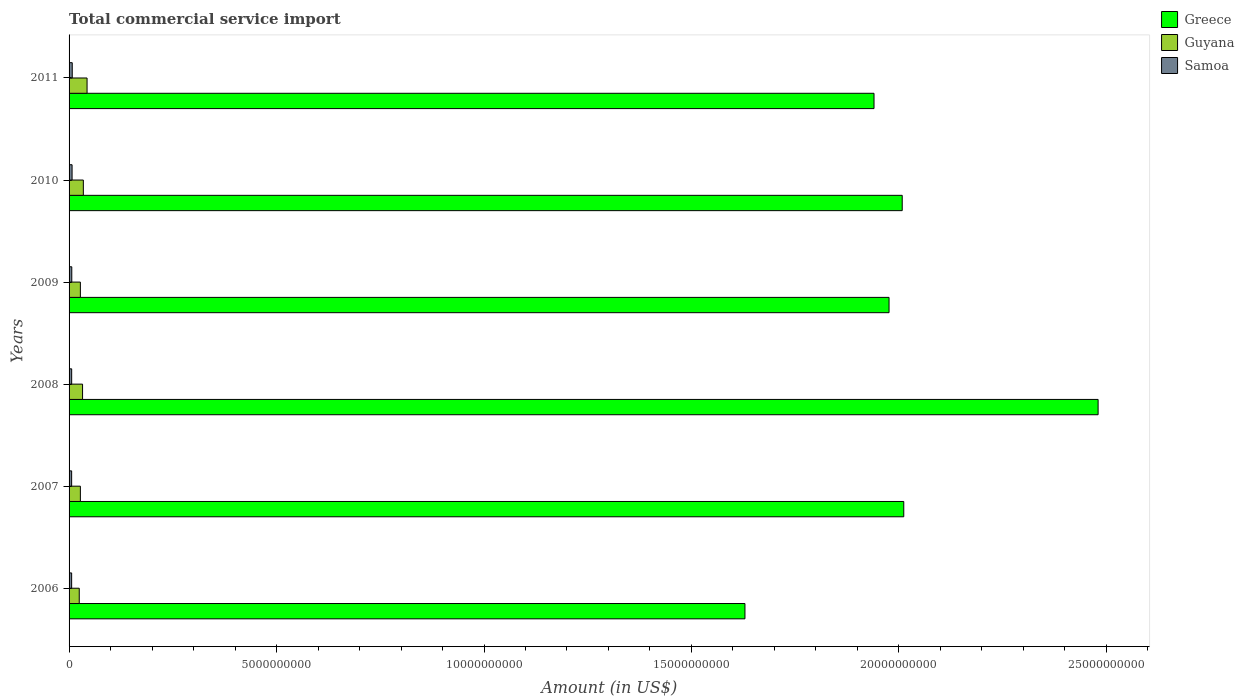How many different coloured bars are there?
Make the answer very short. 3. How many groups of bars are there?
Make the answer very short. 6. Are the number of bars per tick equal to the number of legend labels?
Provide a succinct answer. Yes. How many bars are there on the 1st tick from the top?
Your response must be concise. 3. What is the label of the 6th group of bars from the top?
Make the answer very short. 2006. What is the total commercial service import in Guyana in 2009?
Offer a terse response. 2.72e+08. Across all years, what is the maximum total commercial service import in Greece?
Give a very brief answer. 2.48e+1. Across all years, what is the minimum total commercial service import in Samoa?
Make the answer very short. 6.19e+07. In which year was the total commercial service import in Greece minimum?
Give a very brief answer. 2006. What is the total total commercial service import in Samoa in the graph?
Your answer should be very brief. 4.01e+08. What is the difference between the total commercial service import in Guyana in 2008 and that in 2009?
Provide a succinct answer. 5.28e+07. What is the difference between the total commercial service import in Samoa in 2006 and the total commercial service import in Greece in 2009?
Your answer should be compact. -1.97e+1. What is the average total commercial service import in Samoa per year?
Offer a very short reply. 6.69e+07. In the year 2008, what is the difference between the total commercial service import in Samoa and total commercial service import in Greece?
Provide a short and direct response. -2.47e+1. In how many years, is the total commercial service import in Samoa greater than 8000000000 US$?
Your response must be concise. 0. What is the ratio of the total commercial service import in Samoa in 2008 to that in 2011?
Give a very brief answer. 0.82. Is the total commercial service import in Guyana in 2006 less than that in 2009?
Your answer should be compact. Yes. Is the difference between the total commercial service import in Samoa in 2006 and 2007 greater than the difference between the total commercial service import in Greece in 2006 and 2007?
Provide a succinct answer. Yes. What is the difference between the highest and the second highest total commercial service import in Samoa?
Offer a very short reply. 3.89e+06. What is the difference between the highest and the lowest total commercial service import in Guyana?
Your response must be concise. 1.88e+08. What does the 2nd bar from the top in 2009 represents?
Your response must be concise. Guyana. What does the 3rd bar from the bottom in 2008 represents?
Provide a succinct answer. Samoa. Is it the case that in every year, the sum of the total commercial service import in Guyana and total commercial service import in Samoa is greater than the total commercial service import in Greece?
Your answer should be compact. No. Are all the bars in the graph horizontal?
Ensure brevity in your answer.  Yes. What is the difference between two consecutive major ticks on the X-axis?
Make the answer very short. 5.00e+09. Does the graph contain any zero values?
Your response must be concise. No. Where does the legend appear in the graph?
Give a very brief answer. Top right. How many legend labels are there?
Keep it short and to the point. 3. What is the title of the graph?
Offer a terse response. Total commercial service import. What is the Amount (in US$) in Greece in 2006?
Provide a short and direct response. 1.63e+1. What is the Amount (in US$) of Guyana in 2006?
Your answer should be compact. 2.45e+08. What is the Amount (in US$) of Samoa in 2006?
Provide a succinct answer. 6.19e+07. What is the Amount (in US$) of Greece in 2007?
Give a very brief answer. 2.01e+1. What is the Amount (in US$) in Guyana in 2007?
Provide a short and direct response. 2.73e+08. What is the Amount (in US$) in Samoa in 2007?
Your answer should be compact. 6.21e+07. What is the Amount (in US$) in Greece in 2008?
Your answer should be compact. 2.48e+1. What is the Amount (in US$) in Guyana in 2008?
Make the answer very short. 3.25e+08. What is the Amount (in US$) of Samoa in 2008?
Your response must be concise. 6.28e+07. What is the Amount (in US$) in Greece in 2009?
Ensure brevity in your answer.  1.98e+1. What is the Amount (in US$) in Guyana in 2009?
Ensure brevity in your answer.  2.72e+08. What is the Amount (in US$) of Samoa in 2009?
Provide a short and direct response. 6.55e+07. What is the Amount (in US$) in Greece in 2010?
Give a very brief answer. 2.01e+1. What is the Amount (in US$) of Guyana in 2010?
Provide a short and direct response. 3.44e+08. What is the Amount (in US$) of Samoa in 2010?
Keep it short and to the point. 7.26e+07. What is the Amount (in US$) in Greece in 2011?
Your response must be concise. 1.94e+1. What is the Amount (in US$) of Guyana in 2011?
Provide a short and direct response. 4.34e+08. What is the Amount (in US$) of Samoa in 2011?
Offer a terse response. 7.65e+07. Across all years, what is the maximum Amount (in US$) of Greece?
Provide a short and direct response. 2.48e+1. Across all years, what is the maximum Amount (in US$) in Guyana?
Provide a succinct answer. 4.34e+08. Across all years, what is the maximum Amount (in US$) in Samoa?
Your answer should be compact. 7.65e+07. Across all years, what is the minimum Amount (in US$) of Greece?
Provide a short and direct response. 1.63e+1. Across all years, what is the minimum Amount (in US$) in Guyana?
Make the answer very short. 2.45e+08. Across all years, what is the minimum Amount (in US$) of Samoa?
Offer a terse response. 6.19e+07. What is the total Amount (in US$) of Greece in the graph?
Make the answer very short. 1.20e+11. What is the total Amount (in US$) in Guyana in the graph?
Offer a very short reply. 1.89e+09. What is the total Amount (in US$) in Samoa in the graph?
Offer a very short reply. 4.01e+08. What is the difference between the Amount (in US$) in Greece in 2006 and that in 2007?
Provide a succinct answer. -3.83e+09. What is the difference between the Amount (in US$) in Guyana in 2006 and that in 2007?
Ensure brevity in your answer.  -2.71e+07. What is the difference between the Amount (in US$) in Samoa in 2006 and that in 2007?
Your response must be concise. -1.66e+05. What is the difference between the Amount (in US$) of Greece in 2006 and that in 2008?
Your response must be concise. -8.51e+09. What is the difference between the Amount (in US$) in Guyana in 2006 and that in 2008?
Offer a very short reply. -7.98e+07. What is the difference between the Amount (in US$) of Samoa in 2006 and that in 2008?
Ensure brevity in your answer.  -8.28e+05. What is the difference between the Amount (in US$) of Greece in 2006 and that in 2009?
Offer a very short reply. -3.47e+09. What is the difference between the Amount (in US$) of Guyana in 2006 and that in 2009?
Your response must be concise. -2.70e+07. What is the difference between the Amount (in US$) in Samoa in 2006 and that in 2009?
Provide a short and direct response. -3.52e+06. What is the difference between the Amount (in US$) of Greece in 2006 and that in 2010?
Offer a very short reply. -3.79e+09. What is the difference between the Amount (in US$) of Guyana in 2006 and that in 2010?
Keep it short and to the point. -9.84e+07. What is the difference between the Amount (in US$) in Samoa in 2006 and that in 2010?
Offer a very short reply. -1.07e+07. What is the difference between the Amount (in US$) in Greece in 2006 and that in 2011?
Your answer should be very brief. -3.11e+09. What is the difference between the Amount (in US$) in Guyana in 2006 and that in 2011?
Your answer should be very brief. -1.88e+08. What is the difference between the Amount (in US$) in Samoa in 2006 and that in 2011?
Provide a short and direct response. -1.46e+07. What is the difference between the Amount (in US$) of Greece in 2007 and that in 2008?
Your answer should be compact. -4.68e+09. What is the difference between the Amount (in US$) in Guyana in 2007 and that in 2008?
Ensure brevity in your answer.  -5.27e+07. What is the difference between the Amount (in US$) in Samoa in 2007 and that in 2008?
Give a very brief answer. -6.62e+05. What is the difference between the Amount (in US$) of Greece in 2007 and that in 2009?
Offer a very short reply. 3.55e+08. What is the difference between the Amount (in US$) of Guyana in 2007 and that in 2009?
Offer a very short reply. 1.18e+05. What is the difference between the Amount (in US$) in Samoa in 2007 and that in 2009?
Offer a terse response. -3.36e+06. What is the difference between the Amount (in US$) of Greece in 2007 and that in 2010?
Your answer should be very brief. 3.73e+07. What is the difference between the Amount (in US$) of Guyana in 2007 and that in 2010?
Make the answer very short. -7.13e+07. What is the difference between the Amount (in US$) in Samoa in 2007 and that in 2010?
Ensure brevity in your answer.  -1.05e+07. What is the difference between the Amount (in US$) of Greece in 2007 and that in 2011?
Provide a short and direct response. 7.17e+08. What is the difference between the Amount (in US$) of Guyana in 2007 and that in 2011?
Provide a short and direct response. -1.61e+08. What is the difference between the Amount (in US$) of Samoa in 2007 and that in 2011?
Provide a short and direct response. -1.44e+07. What is the difference between the Amount (in US$) of Greece in 2008 and that in 2009?
Offer a very short reply. 5.04e+09. What is the difference between the Amount (in US$) of Guyana in 2008 and that in 2009?
Your response must be concise. 5.28e+07. What is the difference between the Amount (in US$) of Samoa in 2008 and that in 2009?
Ensure brevity in your answer.  -2.69e+06. What is the difference between the Amount (in US$) in Greece in 2008 and that in 2010?
Make the answer very short. 4.72e+09. What is the difference between the Amount (in US$) in Guyana in 2008 and that in 2010?
Offer a terse response. -1.86e+07. What is the difference between the Amount (in US$) of Samoa in 2008 and that in 2010?
Your answer should be very brief. -9.88e+06. What is the difference between the Amount (in US$) in Greece in 2008 and that in 2011?
Provide a succinct answer. 5.40e+09. What is the difference between the Amount (in US$) in Guyana in 2008 and that in 2011?
Ensure brevity in your answer.  -1.09e+08. What is the difference between the Amount (in US$) of Samoa in 2008 and that in 2011?
Your answer should be compact. -1.38e+07. What is the difference between the Amount (in US$) of Greece in 2009 and that in 2010?
Give a very brief answer. -3.17e+08. What is the difference between the Amount (in US$) of Guyana in 2009 and that in 2010?
Provide a succinct answer. -7.14e+07. What is the difference between the Amount (in US$) in Samoa in 2009 and that in 2010?
Your answer should be compact. -7.18e+06. What is the difference between the Amount (in US$) of Greece in 2009 and that in 2011?
Keep it short and to the point. 3.62e+08. What is the difference between the Amount (in US$) in Guyana in 2009 and that in 2011?
Offer a terse response. -1.61e+08. What is the difference between the Amount (in US$) in Samoa in 2009 and that in 2011?
Offer a very short reply. -1.11e+07. What is the difference between the Amount (in US$) of Greece in 2010 and that in 2011?
Provide a short and direct response. 6.79e+08. What is the difference between the Amount (in US$) in Guyana in 2010 and that in 2011?
Offer a terse response. -8.99e+07. What is the difference between the Amount (in US$) of Samoa in 2010 and that in 2011?
Your answer should be very brief. -3.89e+06. What is the difference between the Amount (in US$) of Greece in 2006 and the Amount (in US$) of Guyana in 2007?
Provide a succinct answer. 1.60e+1. What is the difference between the Amount (in US$) of Greece in 2006 and the Amount (in US$) of Samoa in 2007?
Provide a short and direct response. 1.62e+1. What is the difference between the Amount (in US$) in Guyana in 2006 and the Amount (in US$) in Samoa in 2007?
Provide a short and direct response. 1.83e+08. What is the difference between the Amount (in US$) of Greece in 2006 and the Amount (in US$) of Guyana in 2008?
Offer a very short reply. 1.60e+1. What is the difference between the Amount (in US$) of Greece in 2006 and the Amount (in US$) of Samoa in 2008?
Your response must be concise. 1.62e+1. What is the difference between the Amount (in US$) in Guyana in 2006 and the Amount (in US$) in Samoa in 2008?
Provide a short and direct response. 1.83e+08. What is the difference between the Amount (in US$) in Greece in 2006 and the Amount (in US$) in Guyana in 2009?
Ensure brevity in your answer.  1.60e+1. What is the difference between the Amount (in US$) of Greece in 2006 and the Amount (in US$) of Samoa in 2009?
Offer a very short reply. 1.62e+1. What is the difference between the Amount (in US$) in Guyana in 2006 and the Amount (in US$) in Samoa in 2009?
Keep it short and to the point. 1.80e+08. What is the difference between the Amount (in US$) of Greece in 2006 and the Amount (in US$) of Guyana in 2010?
Your response must be concise. 1.59e+1. What is the difference between the Amount (in US$) of Greece in 2006 and the Amount (in US$) of Samoa in 2010?
Make the answer very short. 1.62e+1. What is the difference between the Amount (in US$) of Guyana in 2006 and the Amount (in US$) of Samoa in 2010?
Give a very brief answer. 1.73e+08. What is the difference between the Amount (in US$) in Greece in 2006 and the Amount (in US$) in Guyana in 2011?
Provide a short and direct response. 1.59e+1. What is the difference between the Amount (in US$) of Greece in 2006 and the Amount (in US$) of Samoa in 2011?
Ensure brevity in your answer.  1.62e+1. What is the difference between the Amount (in US$) of Guyana in 2006 and the Amount (in US$) of Samoa in 2011?
Provide a succinct answer. 1.69e+08. What is the difference between the Amount (in US$) in Greece in 2007 and the Amount (in US$) in Guyana in 2008?
Keep it short and to the point. 1.98e+1. What is the difference between the Amount (in US$) in Greece in 2007 and the Amount (in US$) in Samoa in 2008?
Your answer should be very brief. 2.01e+1. What is the difference between the Amount (in US$) of Guyana in 2007 and the Amount (in US$) of Samoa in 2008?
Your answer should be very brief. 2.10e+08. What is the difference between the Amount (in US$) of Greece in 2007 and the Amount (in US$) of Guyana in 2009?
Give a very brief answer. 1.98e+1. What is the difference between the Amount (in US$) of Greece in 2007 and the Amount (in US$) of Samoa in 2009?
Provide a short and direct response. 2.01e+1. What is the difference between the Amount (in US$) of Guyana in 2007 and the Amount (in US$) of Samoa in 2009?
Your response must be concise. 2.07e+08. What is the difference between the Amount (in US$) in Greece in 2007 and the Amount (in US$) in Guyana in 2010?
Your response must be concise. 1.98e+1. What is the difference between the Amount (in US$) of Greece in 2007 and the Amount (in US$) of Samoa in 2010?
Your answer should be very brief. 2.00e+1. What is the difference between the Amount (in US$) of Guyana in 2007 and the Amount (in US$) of Samoa in 2010?
Offer a terse response. 2.00e+08. What is the difference between the Amount (in US$) of Greece in 2007 and the Amount (in US$) of Guyana in 2011?
Offer a very short reply. 1.97e+1. What is the difference between the Amount (in US$) in Greece in 2007 and the Amount (in US$) in Samoa in 2011?
Offer a very short reply. 2.00e+1. What is the difference between the Amount (in US$) of Guyana in 2007 and the Amount (in US$) of Samoa in 2011?
Give a very brief answer. 1.96e+08. What is the difference between the Amount (in US$) of Greece in 2008 and the Amount (in US$) of Guyana in 2009?
Ensure brevity in your answer.  2.45e+1. What is the difference between the Amount (in US$) of Greece in 2008 and the Amount (in US$) of Samoa in 2009?
Your answer should be compact. 2.47e+1. What is the difference between the Amount (in US$) of Guyana in 2008 and the Amount (in US$) of Samoa in 2009?
Ensure brevity in your answer.  2.60e+08. What is the difference between the Amount (in US$) in Greece in 2008 and the Amount (in US$) in Guyana in 2010?
Your response must be concise. 2.45e+1. What is the difference between the Amount (in US$) of Greece in 2008 and the Amount (in US$) of Samoa in 2010?
Your answer should be compact. 2.47e+1. What is the difference between the Amount (in US$) in Guyana in 2008 and the Amount (in US$) in Samoa in 2010?
Offer a terse response. 2.53e+08. What is the difference between the Amount (in US$) in Greece in 2008 and the Amount (in US$) in Guyana in 2011?
Make the answer very short. 2.44e+1. What is the difference between the Amount (in US$) in Greece in 2008 and the Amount (in US$) in Samoa in 2011?
Keep it short and to the point. 2.47e+1. What is the difference between the Amount (in US$) of Guyana in 2008 and the Amount (in US$) of Samoa in 2011?
Your answer should be very brief. 2.49e+08. What is the difference between the Amount (in US$) in Greece in 2009 and the Amount (in US$) in Guyana in 2010?
Your response must be concise. 1.94e+1. What is the difference between the Amount (in US$) in Greece in 2009 and the Amount (in US$) in Samoa in 2010?
Your response must be concise. 1.97e+1. What is the difference between the Amount (in US$) in Guyana in 2009 and the Amount (in US$) in Samoa in 2010?
Keep it short and to the point. 2.00e+08. What is the difference between the Amount (in US$) of Greece in 2009 and the Amount (in US$) of Guyana in 2011?
Your answer should be very brief. 1.93e+1. What is the difference between the Amount (in US$) of Greece in 2009 and the Amount (in US$) of Samoa in 2011?
Your response must be concise. 1.97e+1. What is the difference between the Amount (in US$) of Guyana in 2009 and the Amount (in US$) of Samoa in 2011?
Give a very brief answer. 1.96e+08. What is the difference between the Amount (in US$) of Greece in 2010 and the Amount (in US$) of Guyana in 2011?
Provide a succinct answer. 1.96e+1. What is the difference between the Amount (in US$) of Greece in 2010 and the Amount (in US$) of Samoa in 2011?
Your answer should be compact. 2.00e+1. What is the difference between the Amount (in US$) of Guyana in 2010 and the Amount (in US$) of Samoa in 2011?
Your answer should be very brief. 2.67e+08. What is the average Amount (in US$) in Greece per year?
Your response must be concise. 2.01e+1. What is the average Amount (in US$) in Guyana per year?
Provide a succinct answer. 3.16e+08. What is the average Amount (in US$) in Samoa per year?
Give a very brief answer. 6.69e+07. In the year 2006, what is the difference between the Amount (in US$) of Greece and Amount (in US$) of Guyana?
Provide a succinct answer. 1.60e+1. In the year 2006, what is the difference between the Amount (in US$) in Greece and Amount (in US$) in Samoa?
Ensure brevity in your answer.  1.62e+1. In the year 2006, what is the difference between the Amount (in US$) of Guyana and Amount (in US$) of Samoa?
Provide a short and direct response. 1.83e+08. In the year 2007, what is the difference between the Amount (in US$) in Greece and Amount (in US$) in Guyana?
Your answer should be compact. 1.98e+1. In the year 2007, what is the difference between the Amount (in US$) of Greece and Amount (in US$) of Samoa?
Keep it short and to the point. 2.01e+1. In the year 2007, what is the difference between the Amount (in US$) in Guyana and Amount (in US$) in Samoa?
Provide a short and direct response. 2.10e+08. In the year 2008, what is the difference between the Amount (in US$) of Greece and Amount (in US$) of Guyana?
Offer a very short reply. 2.45e+1. In the year 2008, what is the difference between the Amount (in US$) of Greece and Amount (in US$) of Samoa?
Offer a terse response. 2.47e+1. In the year 2008, what is the difference between the Amount (in US$) of Guyana and Amount (in US$) of Samoa?
Your answer should be very brief. 2.62e+08. In the year 2009, what is the difference between the Amount (in US$) in Greece and Amount (in US$) in Guyana?
Make the answer very short. 1.95e+1. In the year 2009, what is the difference between the Amount (in US$) in Greece and Amount (in US$) in Samoa?
Provide a short and direct response. 1.97e+1. In the year 2009, what is the difference between the Amount (in US$) in Guyana and Amount (in US$) in Samoa?
Your answer should be compact. 2.07e+08. In the year 2010, what is the difference between the Amount (in US$) in Greece and Amount (in US$) in Guyana?
Provide a succinct answer. 1.97e+1. In the year 2010, what is the difference between the Amount (in US$) in Greece and Amount (in US$) in Samoa?
Keep it short and to the point. 2.00e+1. In the year 2010, what is the difference between the Amount (in US$) in Guyana and Amount (in US$) in Samoa?
Your answer should be very brief. 2.71e+08. In the year 2011, what is the difference between the Amount (in US$) in Greece and Amount (in US$) in Guyana?
Your answer should be compact. 1.90e+1. In the year 2011, what is the difference between the Amount (in US$) of Greece and Amount (in US$) of Samoa?
Your answer should be compact. 1.93e+1. In the year 2011, what is the difference between the Amount (in US$) of Guyana and Amount (in US$) of Samoa?
Your response must be concise. 3.57e+08. What is the ratio of the Amount (in US$) in Greece in 2006 to that in 2007?
Your answer should be very brief. 0.81. What is the ratio of the Amount (in US$) in Guyana in 2006 to that in 2007?
Your answer should be compact. 0.9. What is the ratio of the Amount (in US$) in Greece in 2006 to that in 2008?
Keep it short and to the point. 0.66. What is the ratio of the Amount (in US$) of Guyana in 2006 to that in 2008?
Your response must be concise. 0.75. What is the ratio of the Amount (in US$) in Greece in 2006 to that in 2009?
Your answer should be very brief. 0.82. What is the ratio of the Amount (in US$) of Guyana in 2006 to that in 2009?
Keep it short and to the point. 0.9. What is the ratio of the Amount (in US$) in Samoa in 2006 to that in 2009?
Ensure brevity in your answer.  0.95. What is the ratio of the Amount (in US$) of Greece in 2006 to that in 2010?
Your answer should be compact. 0.81. What is the ratio of the Amount (in US$) in Guyana in 2006 to that in 2010?
Keep it short and to the point. 0.71. What is the ratio of the Amount (in US$) in Samoa in 2006 to that in 2010?
Your response must be concise. 0.85. What is the ratio of the Amount (in US$) of Greece in 2006 to that in 2011?
Provide a short and direct response. 0.84. What is the ratio of the Amount (in US$) in Guyana in 2006 to that in 2011?
Make the answer very short. 0.57. What is the ratio of the Amount (in US$) in Samoa in 2006 to that in 2011?
Give a very brief answer. 0.81. What is the ratio of the Amount (in US$) of Greece in 2007 to that in 2008?
Your response must be concise. 0.81. What is the ratio of the Amount (in US$) in Guyana in 2007 to that in 2008?
Make the answer very short. 0.84. What is the ratio of the Amount (in US$) in Greece in 2007 to that in 2009?
Your response must be concise. 1.02. What is the ratio of the Amount (in US$) in Guyana in 2007 to that in 2009?
Your answer should be very brief. 1. What is the ratio of the Amount (in US$) of Samoa in 2007 to that in 2009?
Provide a short and direct response. 0.95. What is the ratio of the Amount (in US$) of Greece in 2007 to that in 2010?
Your response must be concise. 1. What is the ratio of the Amount (in US$) of Guyana in 2007 to that in 2010?
Provide a succinct answer. 0.79. What is the ratio of the Amount (in US$) in Samoa in 2007 to that in 2010?
Offer a very short reply. 0.85. What is the ratio of the Amount (in US$) of Greece in 2007 to that in 2011?
Your answer should be very brief. 1.04. What is the ratio of the Amount (in US$) of Guyana in 2007 to that in 2011?
Offer a terse response. 0.63. What is the ratio of the Amount (in US$) in Samoa in 2007 to that in 2011?
Make the answer very short. 0.81. What is the ratio of the Amount (in US$) in Greece in 2008 to that in 2009?
Offer a very short reply. 1.25. What is the ratio of the Amount (in US$) in Guyana in 2008 to that in 2009?
Your answer should be compact. 1.19. What is the ratio of the Amount (in US$) in Samoa in 2008 to that in 2009?
Your response must be concise. 0.96. What is the ratio of the Amount (in US$) in Greece in 2008 to that in 2010?
Provide a short and direct response. 1.24. What is the ratio of the Amount (in US$) in Guyana in 2008 to that in 2010?
Ensure brevity in your answer.  0.95. What is the ratio of the Amount (in US$) in Samoa in 2008 to that in 2010?
Ensure brevity in your answer.  0.86. What is the ratio of the Amount (in US$) in Greece in 2008 to that in 2011?
Offer a terse response. 1.28. What is the ratio of the Amount (in US$) in Guyana in 2008 to that in 2011?
Give a very brief answer. 0.75. What is the ratio of the Amount (in US$) of Samoa in 2008 to that in 2011?
Give a very brief answer. 0.82. What is the ratio of the Amount (in US$) of Greece in 2009 to that in 2010?
Offer a terse response. 0.98. What is the ratio of the Amount (in US$) in Guyana in 2009 to that in 2010?
Provide a succinct answer. 0.79. What is the ratio of the Amount (in US$) in Samoa in 2009 to that in 2010?
Provide a short and direct response. 0.9. What is the ratio of the Amount (in US$) in Greece in 2009 to that in 2011?
Your answer should be compact. 1.02. What is the ratio of the Amount (in US$) of Guyana in 2009 to that in 2011?
Make the answer very short. 0.63. What is the ratio of the Amount (in US$) of Samoa in 2009 to that in 2011?
Offer a very short reply. 0.86. What is the ratio of the Amount (in US$) of Greece in 2010 to that in 2011?
Keep it short and to the point. 1.03. What is the ratio of the Amount (in US$) of Guyana in 2010 to that in 2011?
Offer a very short reply. 0.79. What is the ratio of the Amount (in US$) of Samoa in 2010 to that in 2011?
Provide a short and direct response. 0.95. What is the difference between the highest and the second highest Amount (in US$) in Greece?
Your response must be concise. 4.68e+09. What is the difference between the highest and the second highest Amount (in US$) of Guyana?
Ensure brevity in your answer.  8.99e+07. What is the difference between the highest and the second highest Amount (in US$) in Samoa?
Give a very brief answer. 3.89e+06. What is the difference between the highest and the lowest Amount (in US$) in Greece?
Offer a terse response. 8.51e+09. What is the difference between the highest and the lowest Amount (in US$) of Guyana?
Ensure brevity in your answer.  1.88e+08. What is the difference between the highest and the lowest Amount (in US$) of Samoa?
Offer a terse response. 1.46e+07. 